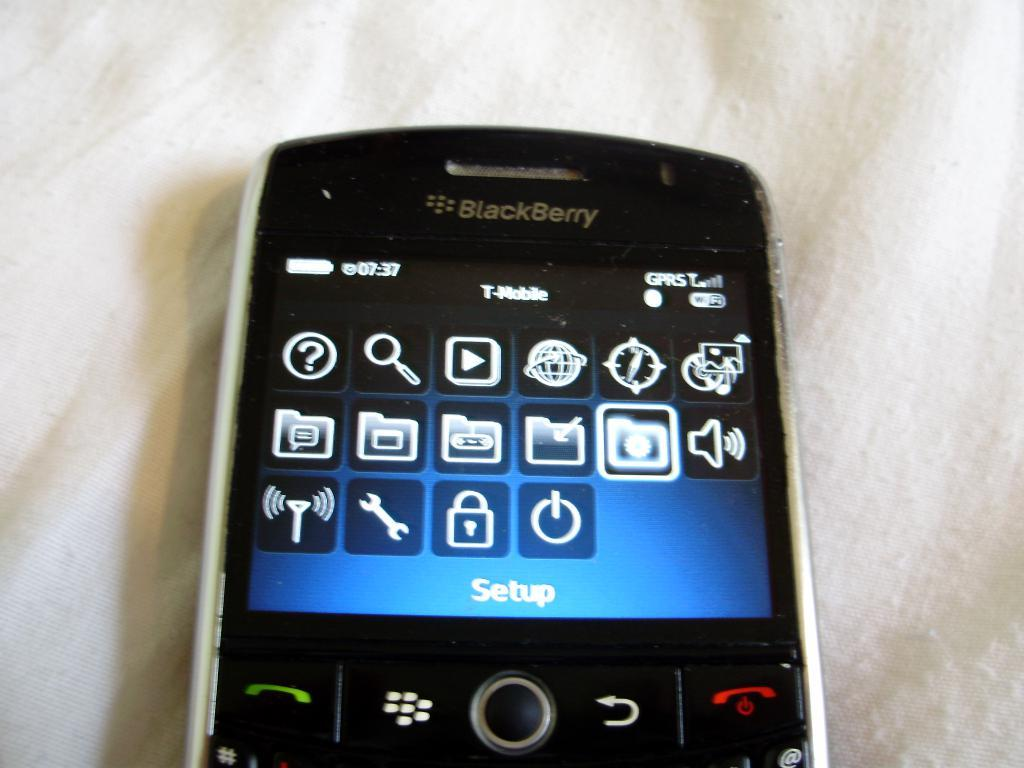What type of mobile phone is visible in the image? There is a blackberry mobile phone in the image. What color is the surface on which the mobile phone is placed? The mobile phone is on a white surface. What types of plants can be seen growing in the town depicted in the image? There is no town or plants present in the image; it only features a blackberry mobile phone on a white surface. 